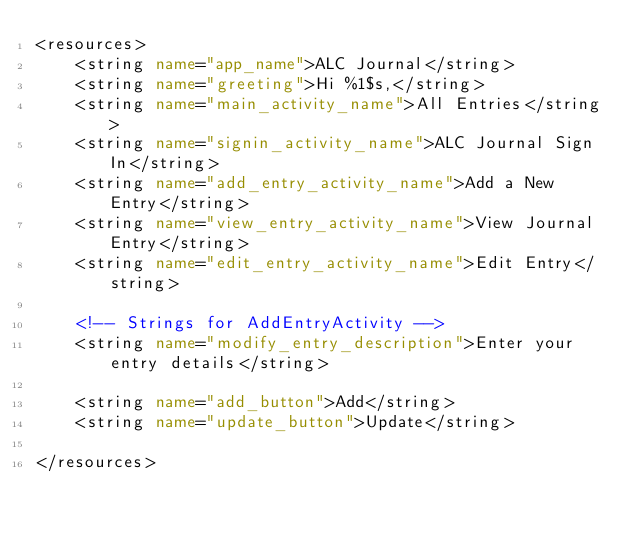Convert code to text. <code><loc_0><loc_0><loc_500><loc_500><_XML_><resources>
    <string name="app_name">ALC Journal</string>
    <string name="greeting">Hi %1$s,</string>
    <string name="main_activity_name">All Entries</string>
    <string name="signin_activity_name">ALC Journal Sign In</string>
    <string name="add_entry_activity_name">Add a New Entry</string>
    <string name="view_entry_activity_name">View Journal Entry</string>
    <string name="edit_entry_activity_name">Edit Entry</string>

    <!-- Strings for AddEntryActivity -->
    <string name="modify_entry_description">Enter your entry details</string>

    <string name="add_button">Add</string>
    <string name="update_button">Update</string>

</resources>
</code> 